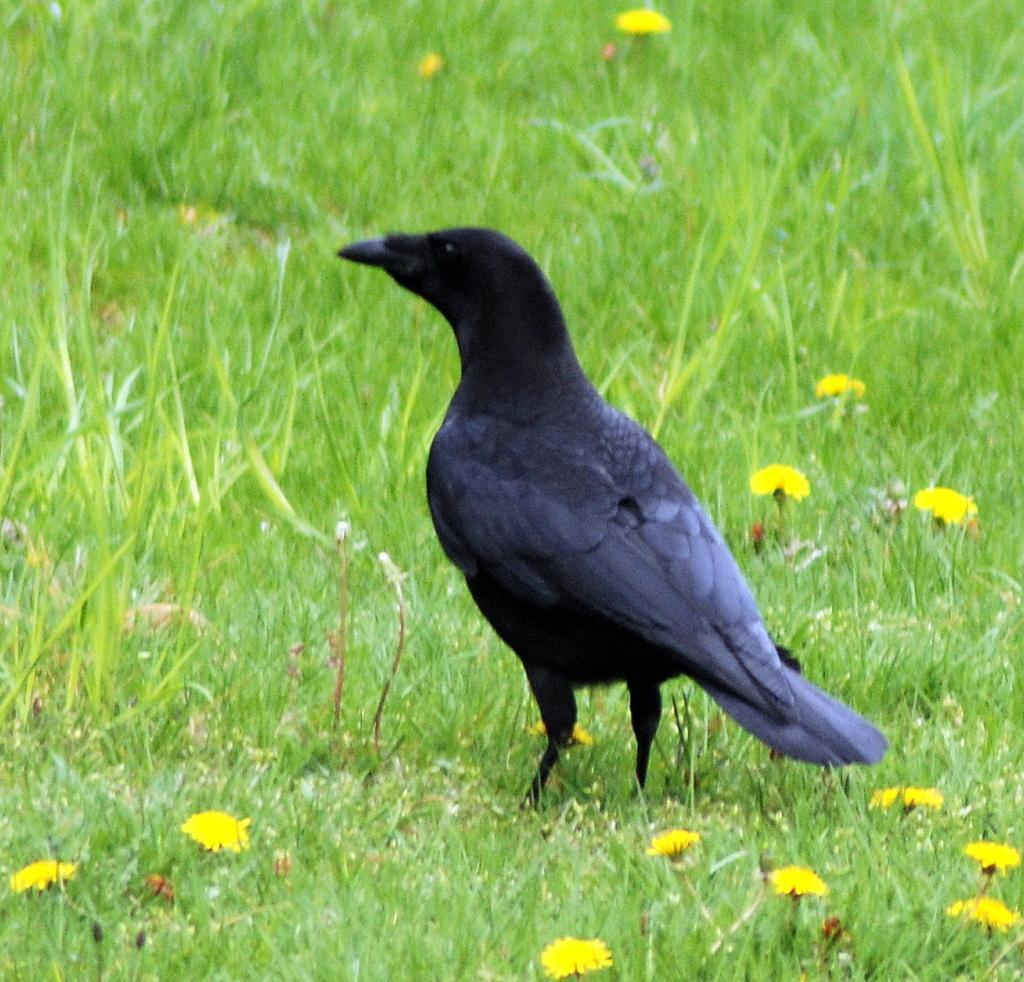In one or two sentences, can you explain what this image depicts? In this image there is a crow standing on the ground. At the bottom there are yellow color flowers and grass. 